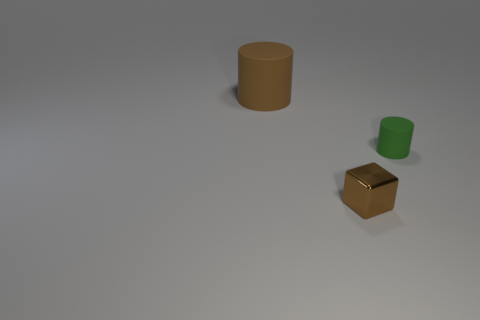There is a object to the left of the small cube; are there any cylinders that are on the right side of it?
Your answer should be very brief. Yes. Is the tiny brown thing the same shape as the green rubber object?
Keep it short and to the point. No. There is a matte cylinder that is in front of the large cylinder; is its size the same as the object that is to the left of the tiny brown cube?
Ensure brevity in your answer.  No. Is the number of tiny green things that are behind the large brown matte object greater than the number of tiny green matte things right of the shiny object?
Offer a terse response. No. What number of other objects are there of the same color as the tiny rubber cylinder?
Offer a terse response. 0. There is a big object; is it the same color as the tiny object in front of the green matte object?
Offer a terse response. Yes. How many small blocks are behind the brown object behind the tiny green matte object?
Provide a short and direct response. 0. Are there any other things that are made of the same material as the green cylinder?
Offer a terse response. Yes. What is the material of the small object to the left of the matte cylinder that is on the right side of the matte thing that is to the left of the small cylinder?
Offer a terse response. Metal. The thing that is behind the tiny shiny thing and to the left of the green cylinder is made of what material?
Offer a very short reply. Rubber. 